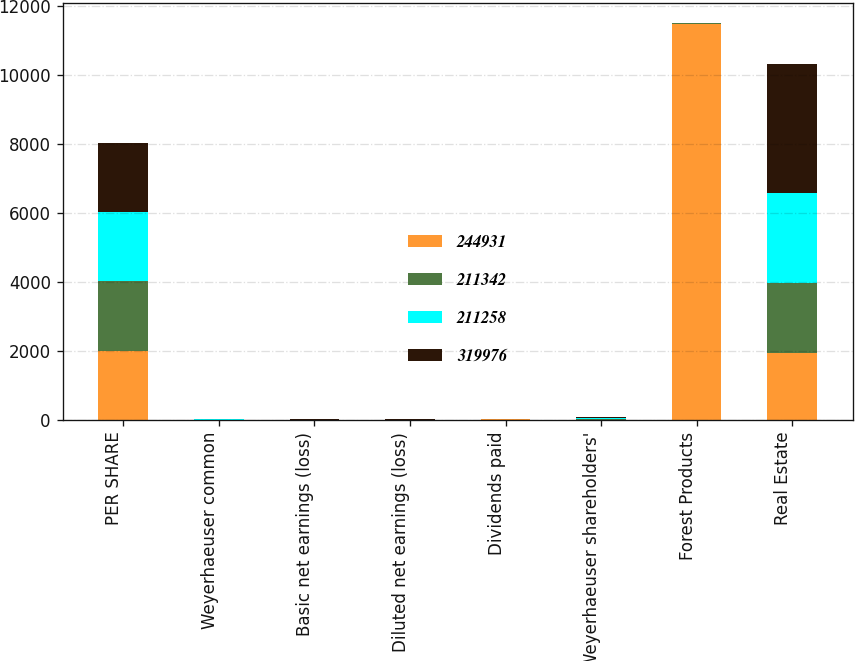Convert chart to OTSL. <chart><loc_0><loc_0><loc_500><loc_500><stacked_bar_chart><ecel><fcel>PER SHARE<fcel>Weyerhaeuser common<fcel>Basic net earnings (loss)<fcel>Diluted net earnings (loss)<fcel>Dividends paid<fcel>Weyerhaeuser shareholders'<fcel>Forest Products<fcel>Real Estate<nl><fcel>244931<fcel>2010<fcel>4<fcel>4<fcel>3.99<fcel>26.61<fcel>8.6<fcel>11476<fcel>1953<nl><fcel>211342<fcel>2009<fcel>2.58<fcel>2.58<fcel>2.58<fcel>0.6<fcel>19.13<fcel>8.6<fcel>2002<nl><fcel>211258<fcel>2008<fcel>8.72<fcel>5.57<fcel>5.57<fcel>2.4<fcel>22.78<fcel>8.6<fcel>2615<nl><fcel>319976<fcel>2007<fcel>1.13<fcel>3.6<fcel>3.6<fcel>2.4<fcel>37.8<fcel>8.6<fcel>3736<nl></chart> 